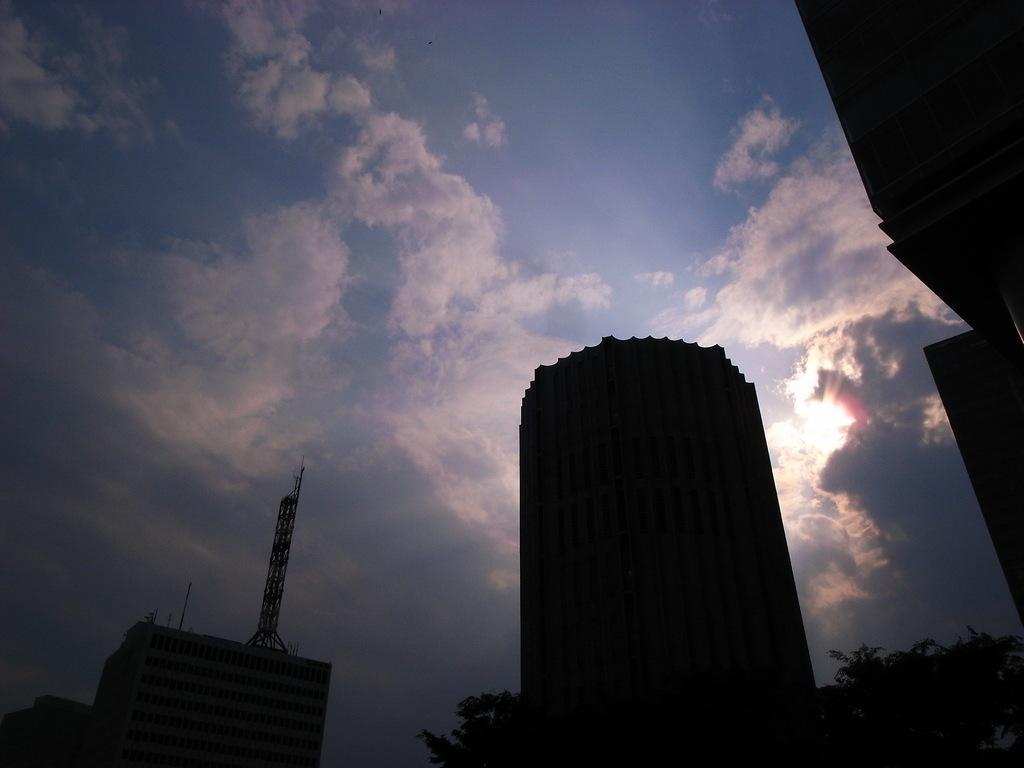Could you give a brief overview of what you see in this image? This picture is clicked outside. In the foreground we can see the buildings and trees In the background we can see the sky with the clouds and we can see the metal rods and some other objects. 